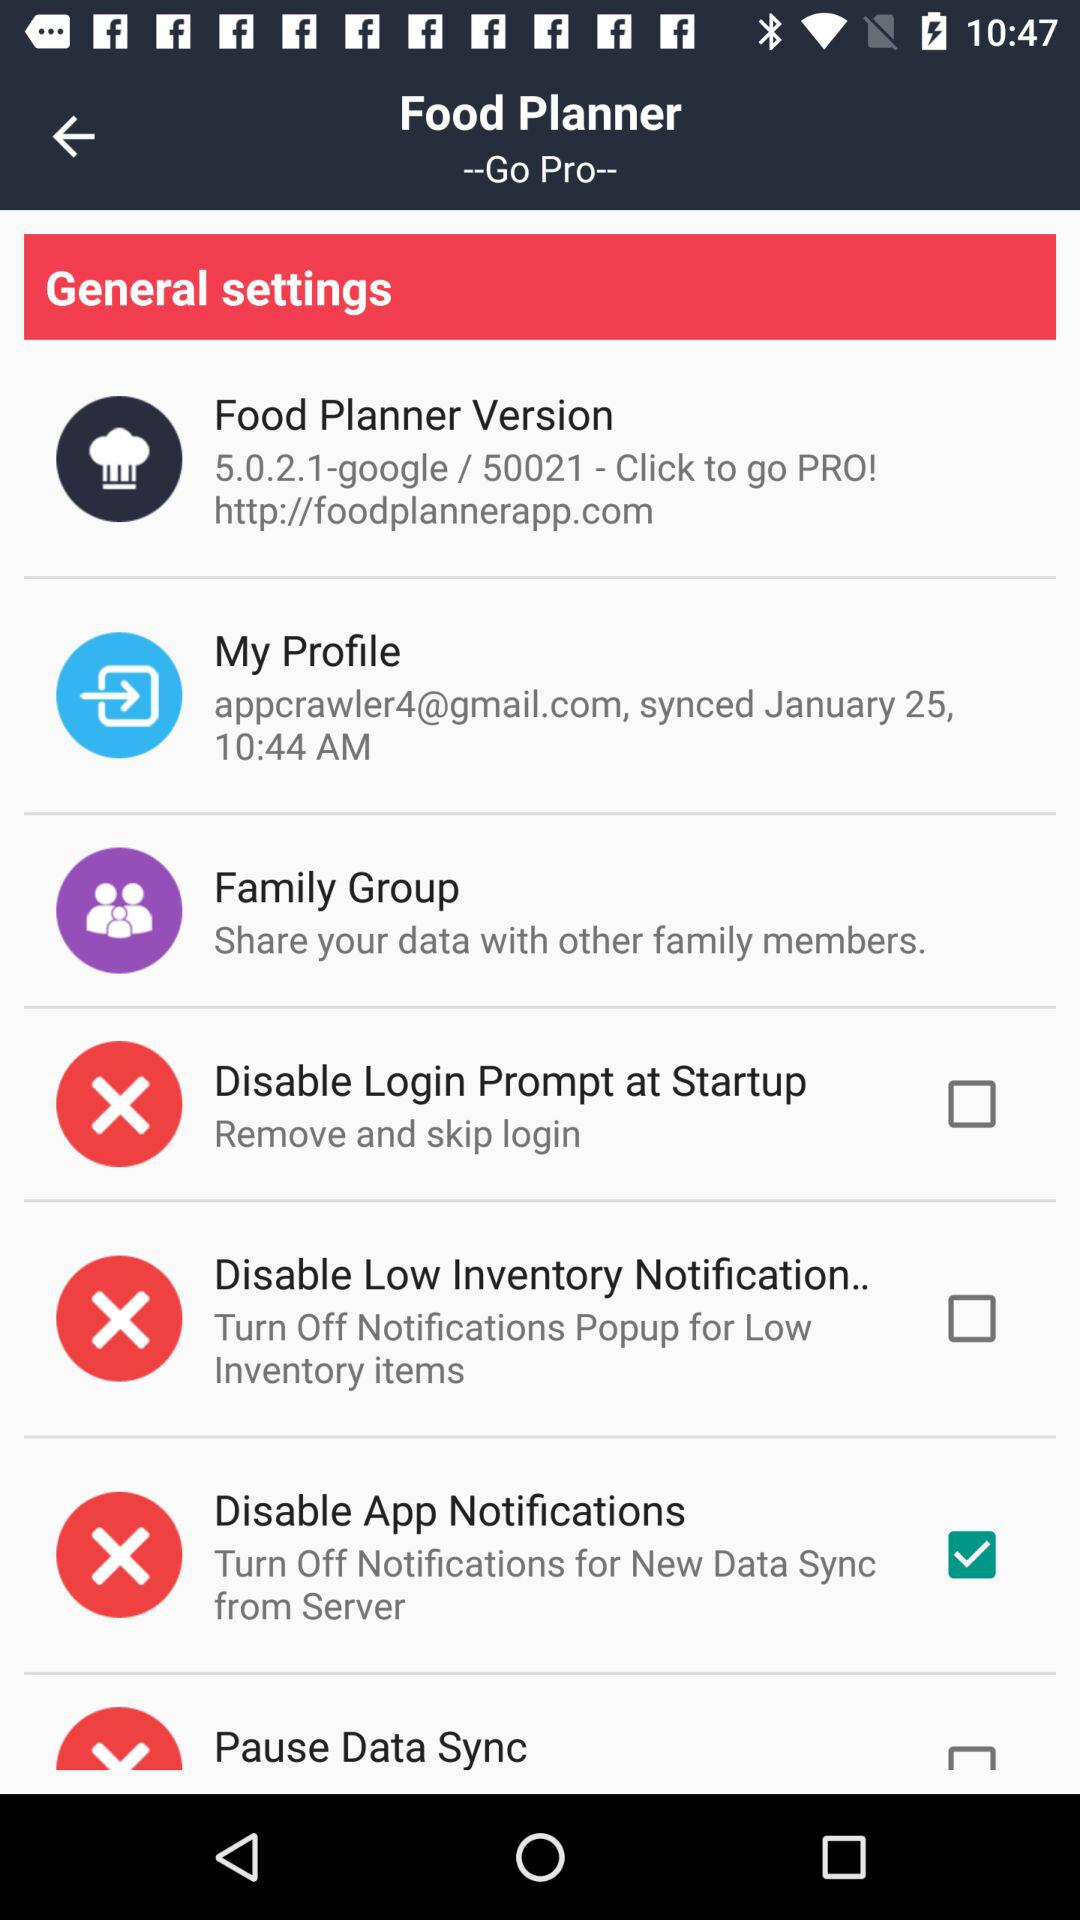What is the synced time of a user? The synced time is 10:44 AM. 